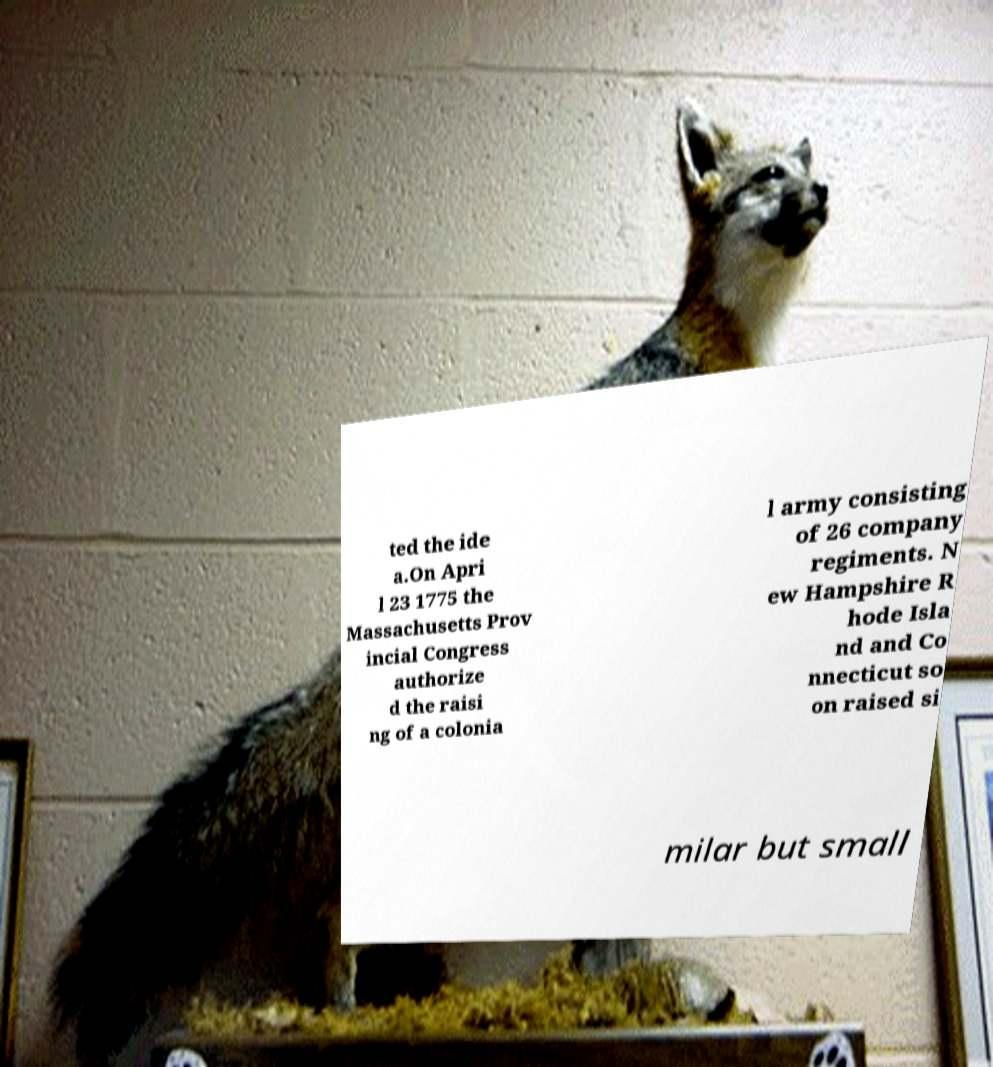I need the written content from this picture converted into text. Can you do that? ted the ide a.On Apri l 23 1775 the Massachusetts Prov incial Congress authorize d the raisi ng of a colonia l army consisting of 26 company regiments. N ew Hampshire R hode Isla nd and Co nnecticut so on raised si milar but small 